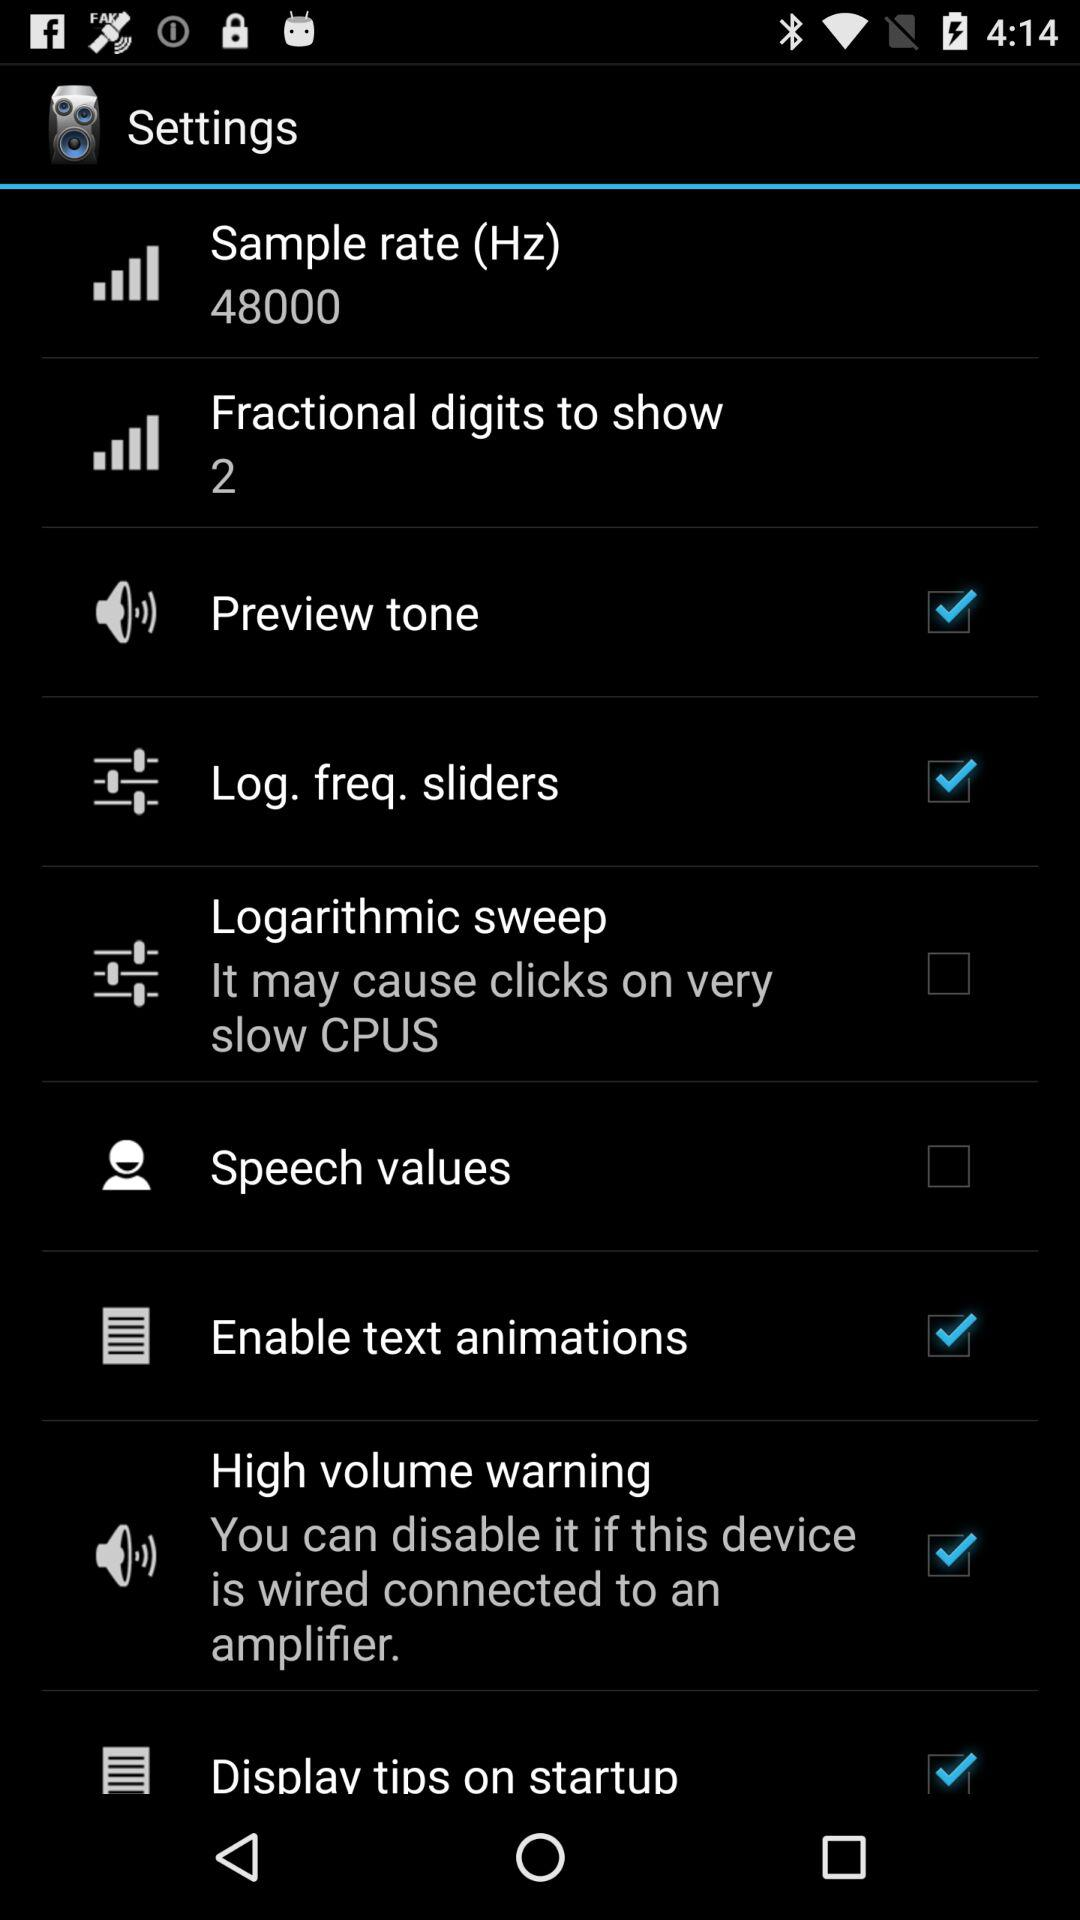What is the status of "Log. freq. sliders"? The status is "on". 